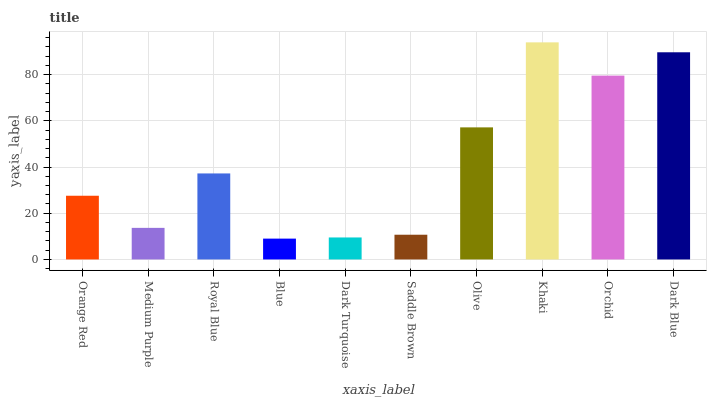Is Blue the minimum?
Answer yes or no. Yes. Is Khaki the maximum?
Answer yes or no. Yes. Is Medium Purple the minimum?
Answer yes or no. No. Is Medium Purple the maximum?
Answer yes or no. No. Is Orange Red greater than Medium Purple?
Answer yes or no. Yes. Is Medium Purple less than Orange Red?
Answer yes or no. Yes. Is Medium Purple greater than Orange Red?
Answer yes or no. No. Is Orange Red less than Medium Purple?
Answer yes or no. No. Is Royal Blue the high median?
Answer yes or no. Yes. Is Orange Red the low median?
Answer yes or no. Yes. Is Medium Purple the high median?
Answer yes or no. No. Is Dark Turquoise the low median?
Answer yes or no. No. 